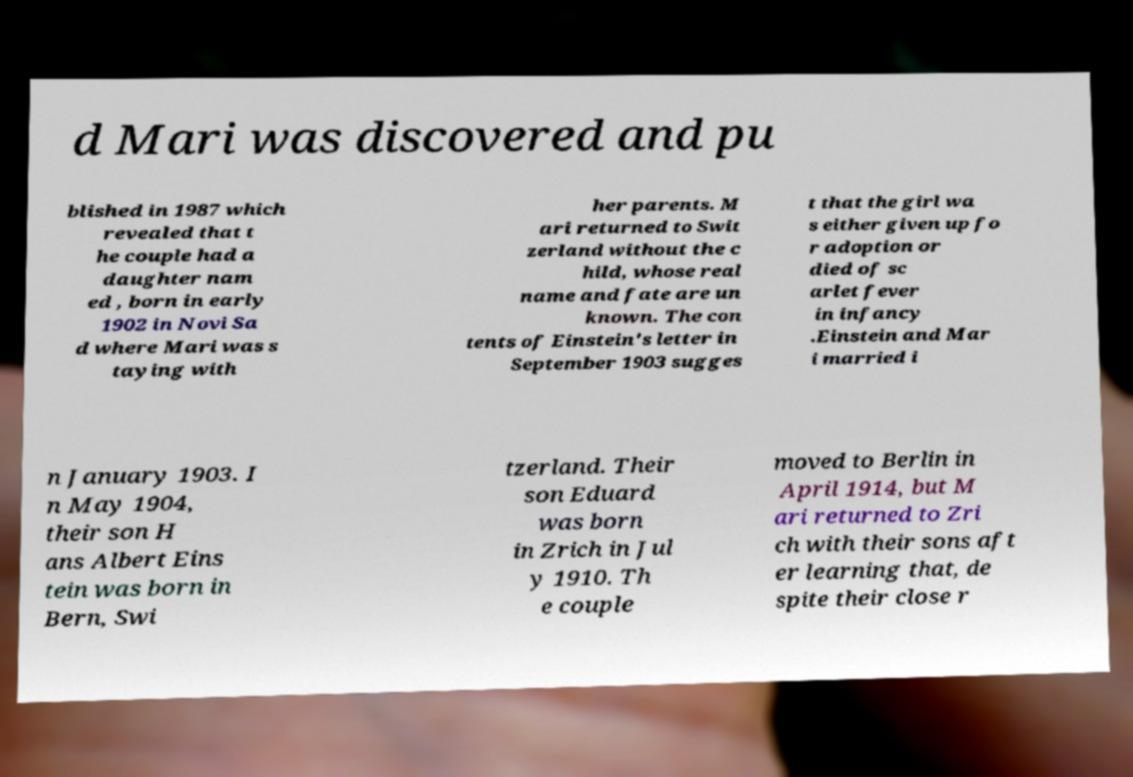There's text embedded in this image that I need extracted. Can you transcribe it verbatim? d Mari was discovered and pu blished in 1987 which revealed that t he couple had a daughter nam ed , born in early 1902 in Novi Sa d where Mari was s taying with her parents. M ari returned to Swit zerland without the c hild, whose real name and fate are un known. The con tents of Einstein's letter in September 1903 sugges t that the girl wa s either given up fo r adoption or died of sc arlet fever in infancy .Einstein and Mar i married i n January 1903. I n May 1904, their son H ans Albert Eins tein was born in Bern, Swi tzerland. Their son Eduard was born in Zrich in Jul y 1910. Th e couple moved to Berlin in April 1914, but M ari returned to Zri ch with their sons aft er learning that, de spite their close r 